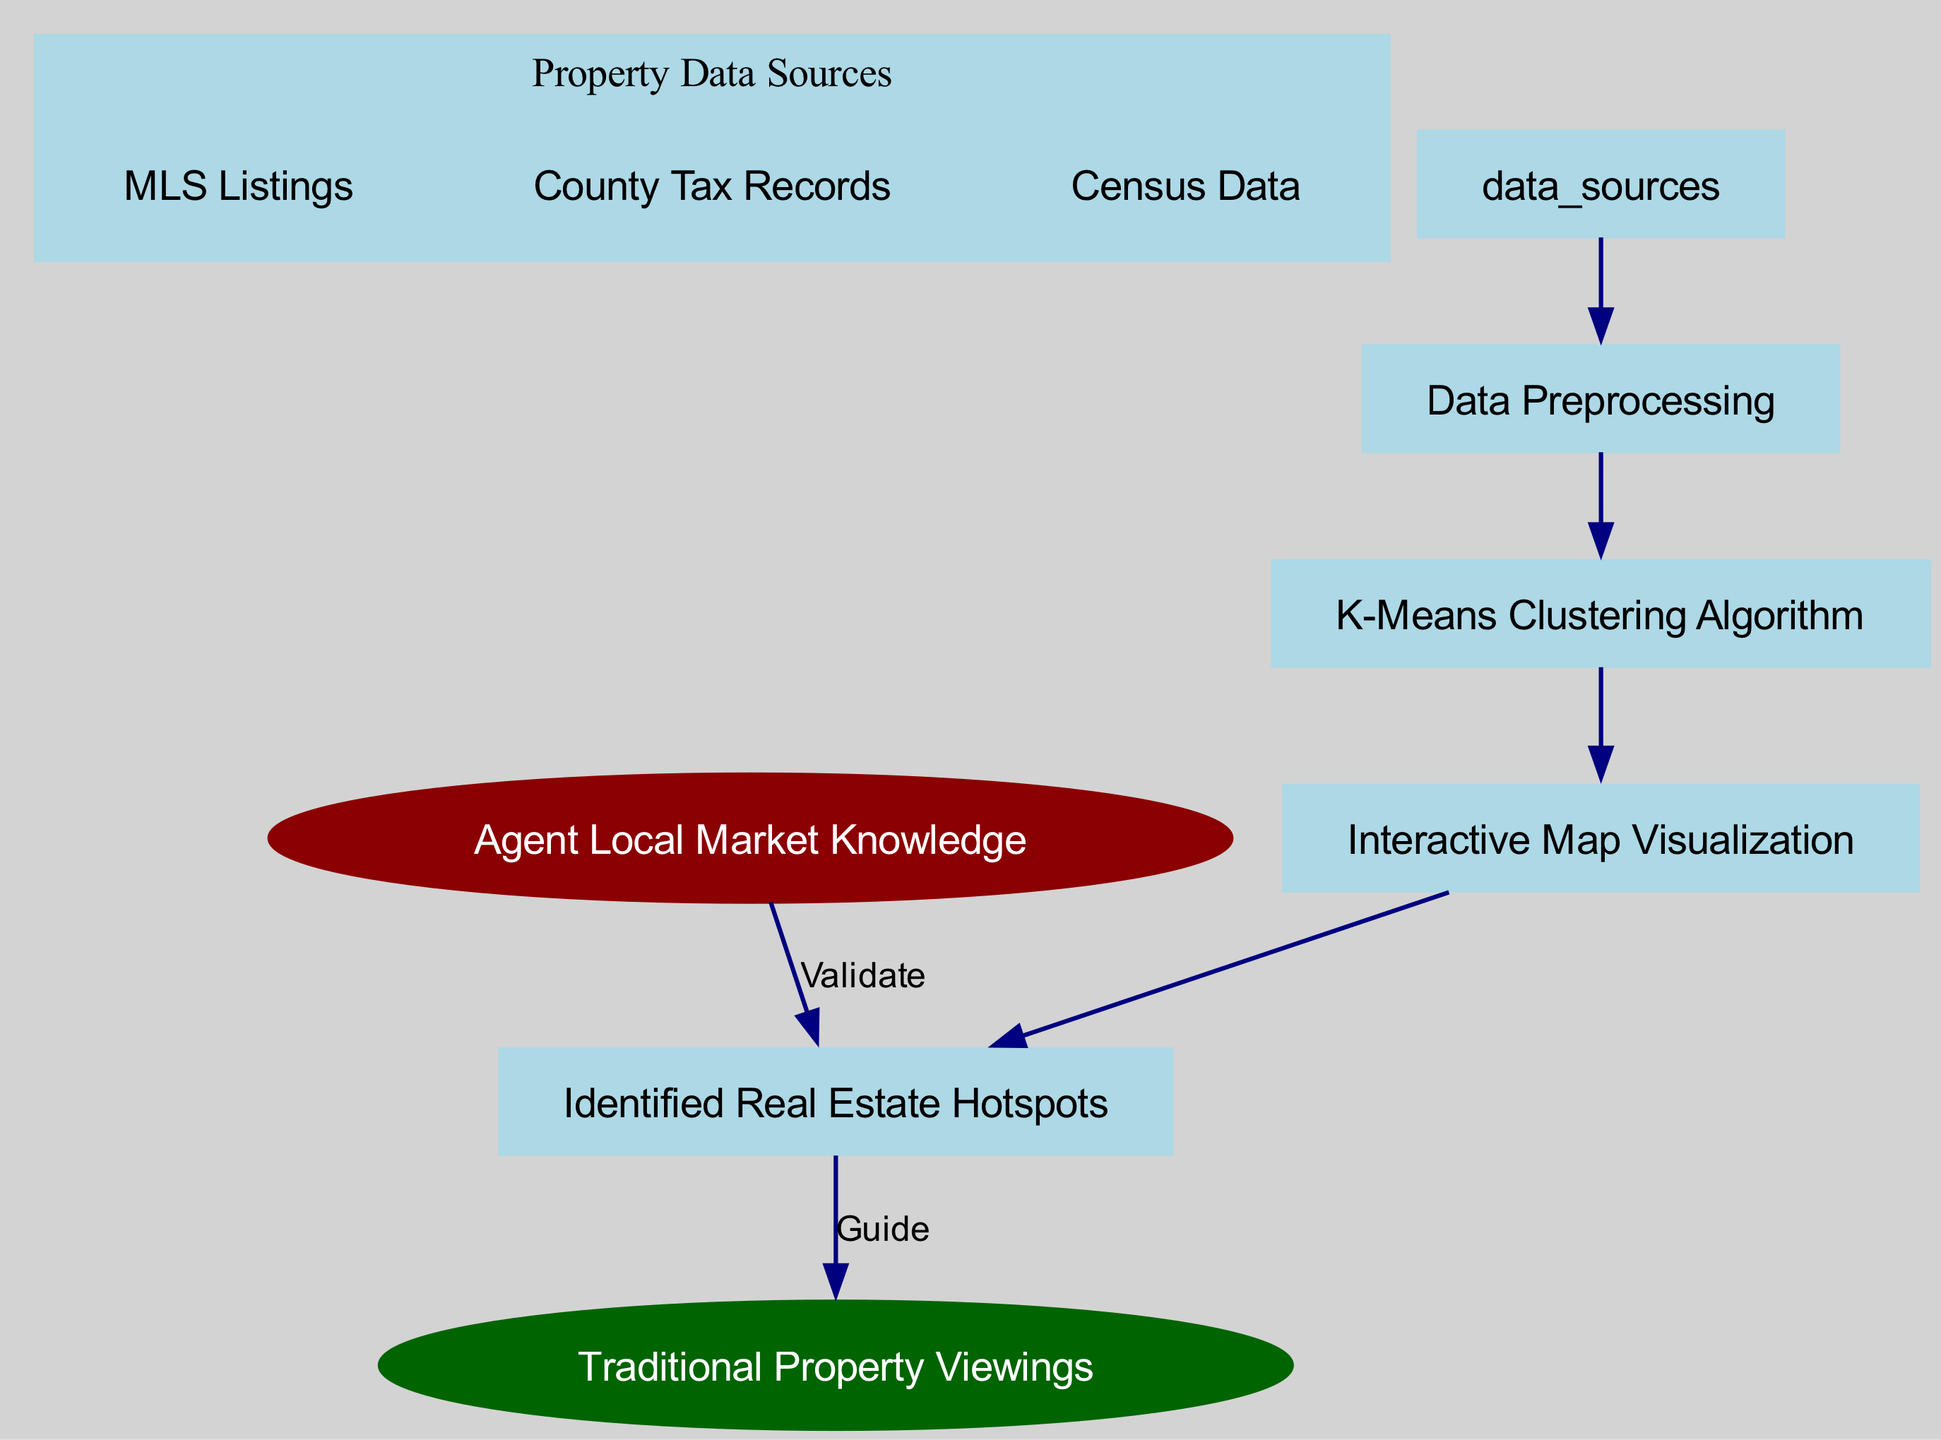What are the data sources for property analysis? The diagram lists three data sources for property analysis: MLS Listings, County Tax Records, and Census Data. These are indicated under the "Property Data Sources" node that directly connects to "Data Preprocessing."
Answer: MLS Listings, County Tax Records, Census Data How many nodes are there in total? To find the total number of nodes, we can count all unique nodes presented in the diagram. There are a total of 7 nodes.
Answer: 7 What is the output of the clustering algorithm? The clustering algorithm uses K-Means Clustering to process the input data and produces an output, which is "Interactive Map Visualization." This is the immediate next node after "K-Means Clustering Algorithm" in the flowchart.
Answer: Interactive Map Visualization Which node validates the identified hotspots? The node that validates the identified hotspots is "Agent Local Market Knowledge." This validation is represented by a directed edge from "Agent Local Market Knowledge" to "Identified Real Estate Hotspots."
Answer: Agent Local Market Knowledge Which node guides to traditional property viewings? The "Identified Real Estate Hotspots" node guides to traditional property viewings represented by a directed edge labeled "Guide." This shows the connection between the hotspots and the physical tours that agents conduct.
Answer: Identified Real Estate Hotspots How many edges are there connecting the nodes? By counting the directed edges shown in the diagram, we find there are 6 edges connecting the various nodes in the flow of the diagram.
Answer: 6 What process follows data preprocessing? The process that follows data preprocessing is "K-Means Clustering Algorithm," which shows that the output of the preprocessing is the input for the clustering technique utilized in this analysis.
Answer: K-Means Clustering Algorithm What is the purpose of the interactive map visualization? The purpose of the interactive map visualization is to represent the identified real estate hotspots graphically, allowing users to see demographic patterns and property values effectively. This is the main output of the clustering process.
Answer: Identified Real Estate Hotspots What type of diagram is this? This is a Machine Learning Diagram, specifically illustrating how clustering algorithms can visualize neighborhood demographics and property values in real estate analysis.
Answer: Machine Learning Diagram 